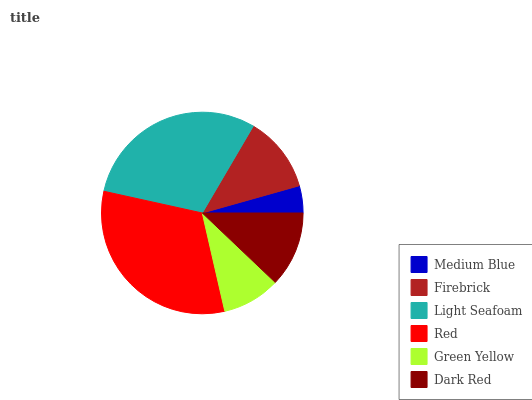Is Medium Blue the minimum?
Answer yes or no. Yes. Is Red the maximum?
Answer yes or no. Yes. Is Firebrick the minimum?
Answer yes or no. No. Is Firebrick the maximum?
Answer yes or no. No. Is Firebrick greater than Medium Blue?
Answer yes or no. Yes. Is Medium Blue less than Firebrick?
Answer yes or no. Yes. Is Medium Blue greater than Firebrick?
Answer yes or no. No. Is Firebrick less than Medium Blue?
Answer yes or no. No. Is Firebrick the high median?
Answer yes or no. Yes. Is Dark Red the low median?
Answer yes or no. Yes. Is Red the high median?
Answer yes or no. No. Is Red the low median?
Answer yes or no. No. 